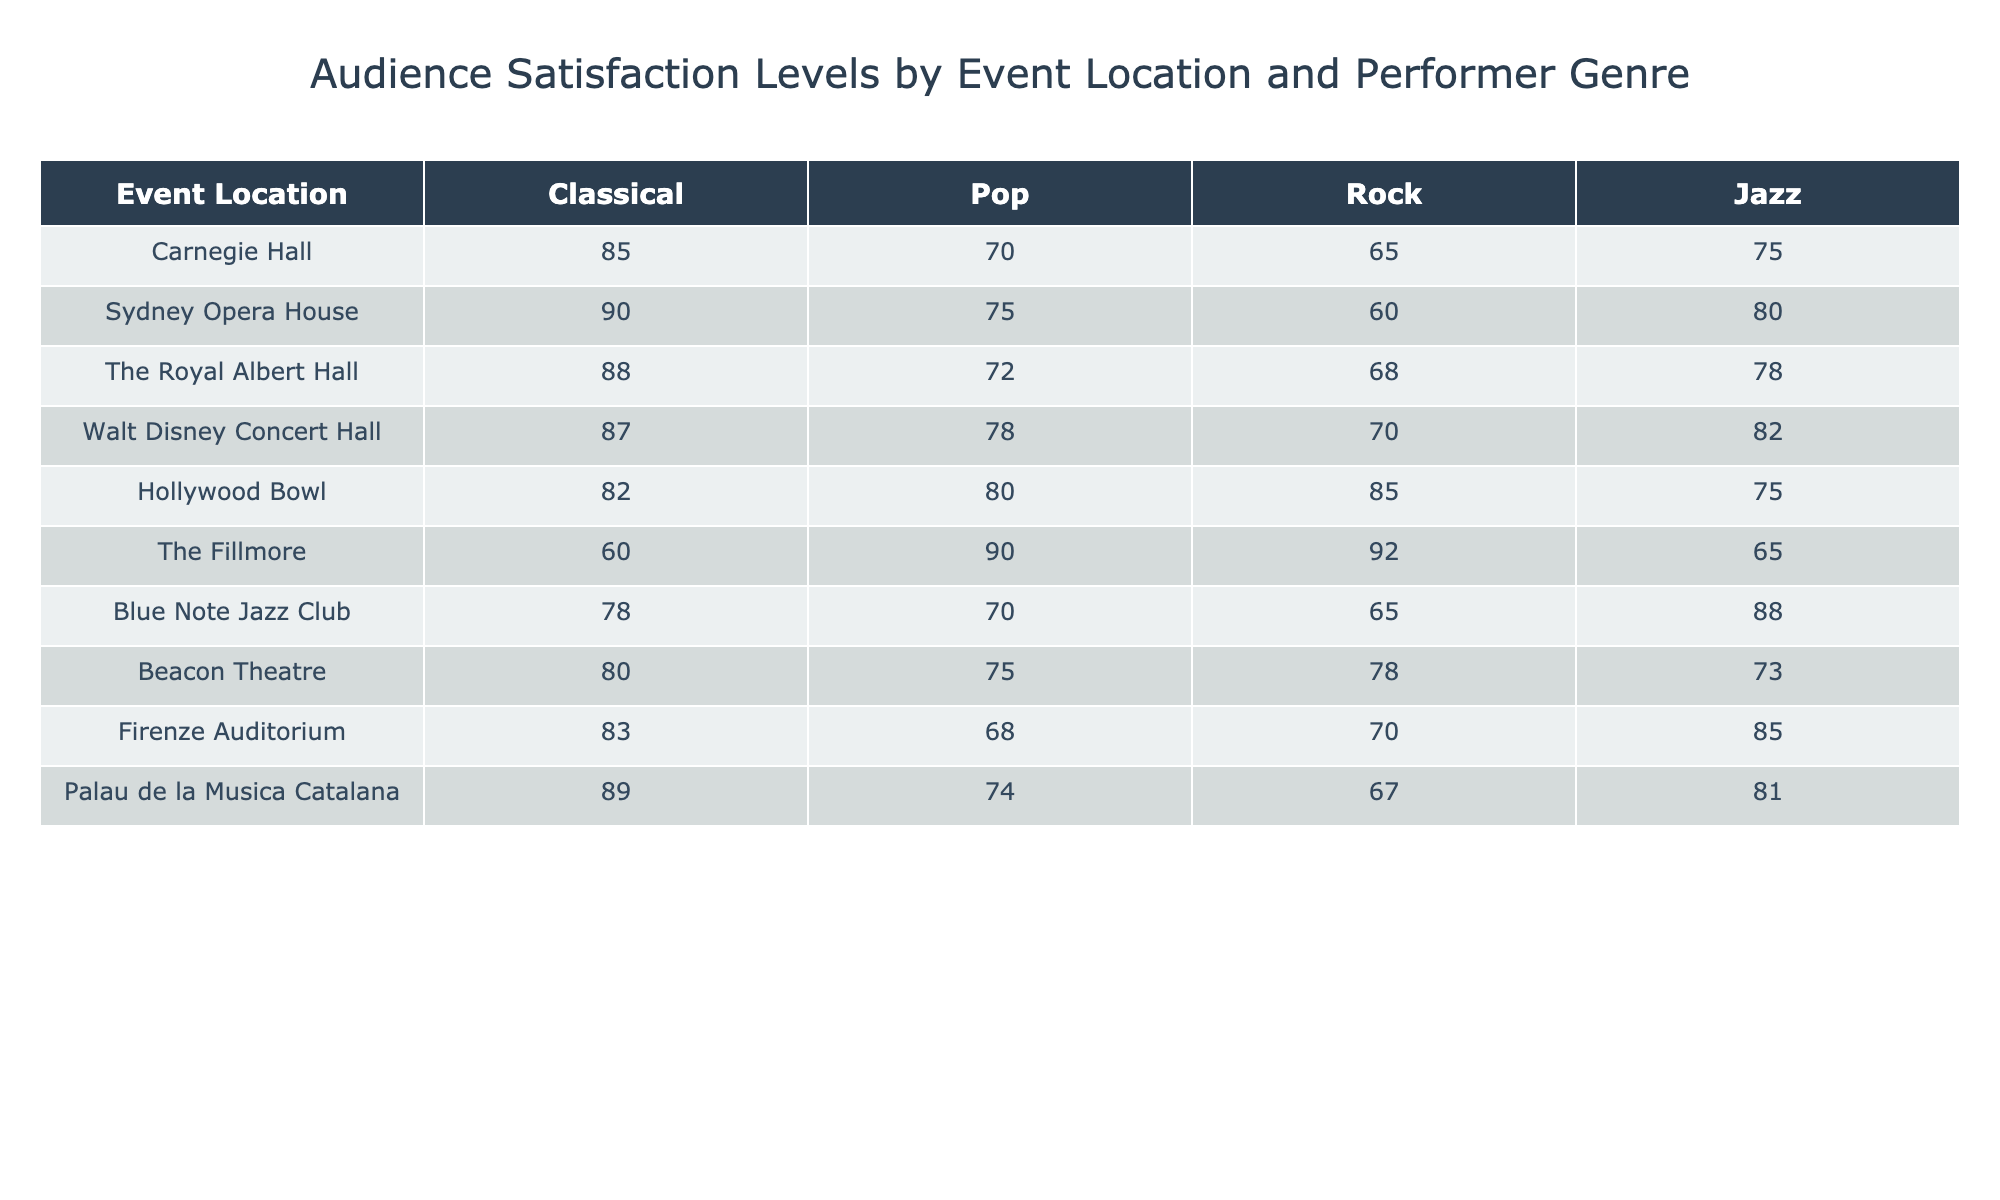What is the satisfaction level for Classical music at the Sydney Opera House? The table indicates that the satisfaction level for Classical music at the Sydney Opera House is 90.
Answer: 90 Which event location has the highest satisfaction level for Jazz? By reviewing the table, the event location with the highest satisfaction level for Jazz is the Blue Note Jazz Club, which has a score of 88.
Answer: Blue Note Jazz Club What is the average satisfaction level for Pop music across all event locations? To find the average for Pop music, we add the satisfaction levels: (70 + 75 + 72 + 78 + 80 + 90 + 70 + 75 + 68 + 74) =  754. There are 10 locations, so the average is 754/10 = 75.4.
Answer: 75.4 Is the satisfaction level for Rock music at the Hollywood Bowl higher than that at the Beacon Theatre? The table shows a satisfaction level of 85 for Rock music at the Hollywood Bowl and 78 at the Beacon Theatre. Thus, 85 is greater than 78, which means the statement is true.
Answer: Yes Which genres have a satisfaction level above 85 at any venue? By reviewing the table, the genres that have satisfaction levels above 85 are Classical at Carnegie Hall (85), Classical at Sydney Opera House (90), Classical at Palau de la Musica Catalana (89), and Rock at the Fillmore (92). Therefore, multiple genres exceed 85 satisfaction levels in different venues.
Answer: Classical, Rock What is the difference in satisfaction levels for Jazz between the Walt Disney Concert Hall and the Royal Albert Hall? The Walt Disney Concert Hall has a satisfaction level of 82 for Jazz, while the Royal Albert Hall has a level of 78. The difference is 82 - 78 = 4.
Answer: 4 Did all event locations achieve a satisfaction level of 70 or higher for Classical music? Reviewing the table, all locations listed have satisfaction levels for Classical music above 70, confirming the statement is true.
Answer: Yes Which event location has the lowest satisfaction level, and in which genre? According to the table, The Fillmore has the lowest satisfaction level of 60 for Pop music.
Answer: The Fillmore, Pop 